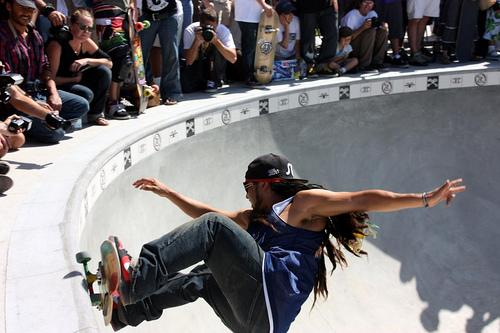What is the person in the foreground doing? skateboarding 